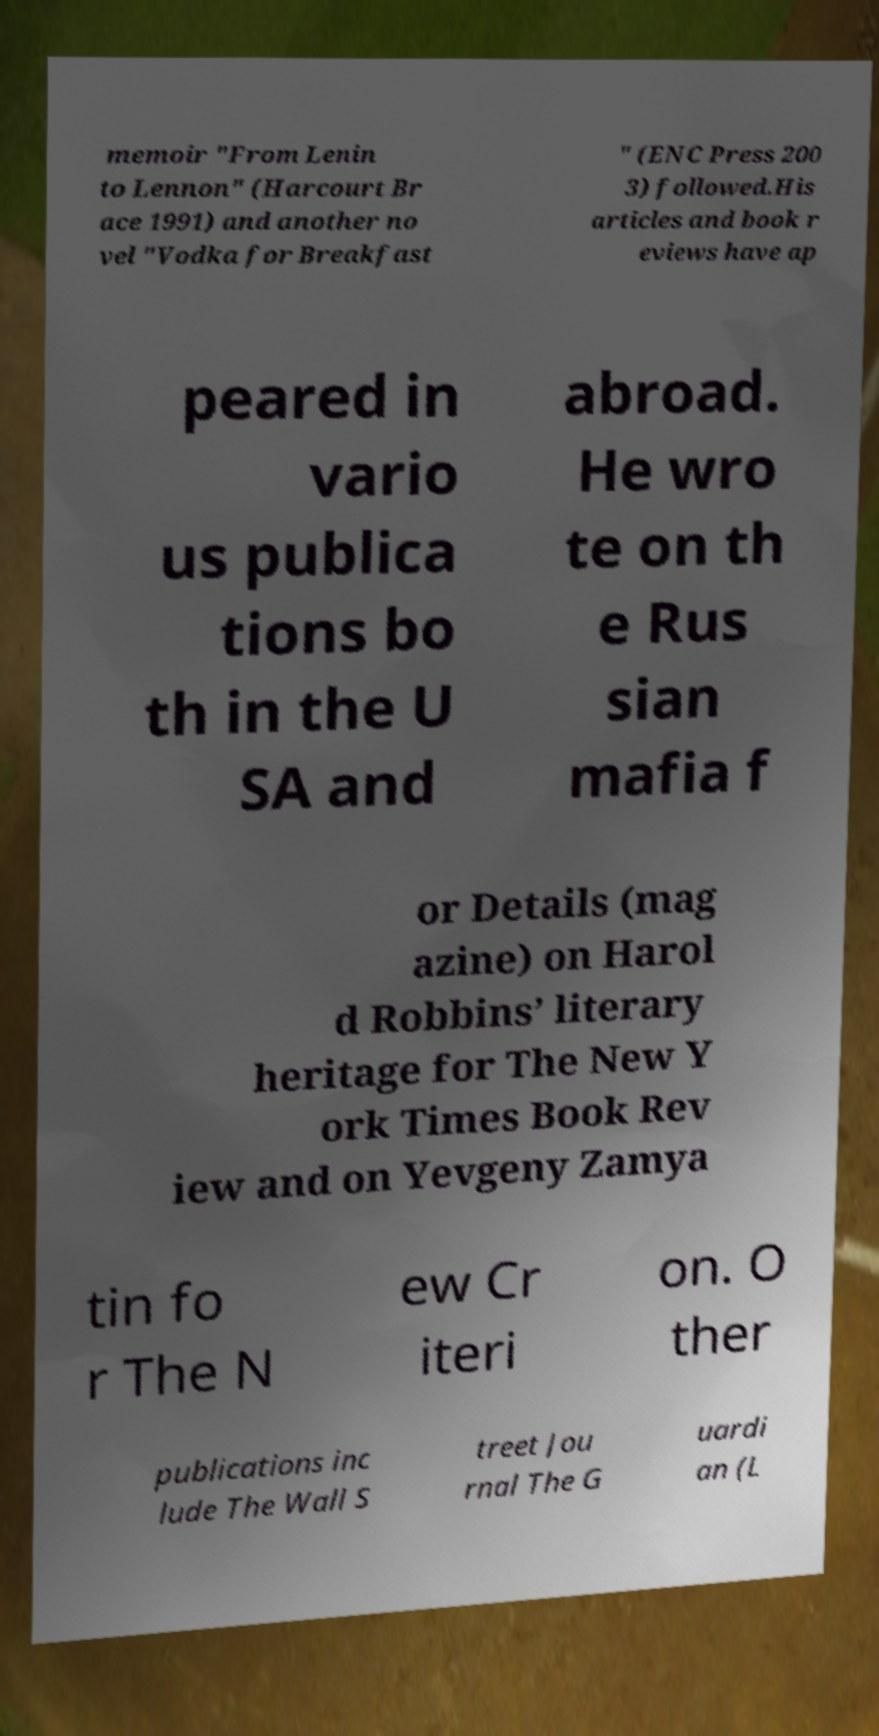Can you read and provide the text displayed in the image?This photo seems to have some interesting text. Can you extract and type it out for me? memoir "From Lenin to Lennon" (Harcourt Br ace 1991) and another no vel "Vodka for Breakfast " (ENC Press 200 3) followed.His articles and book r eviews have ap peared in vario us publica tions bo th in the U SA and abroad. He wro te on th e Rus sian mafia f or Details (mag azine) on Harol d Robbins’ literary heritage for The New Y ork Times Book Rev iew and on Yevgeny Zamya tin fo r The N ew Cr iteri on. O ther publications inc lude The Wall S treet Jou rnal The G uardi an (L 